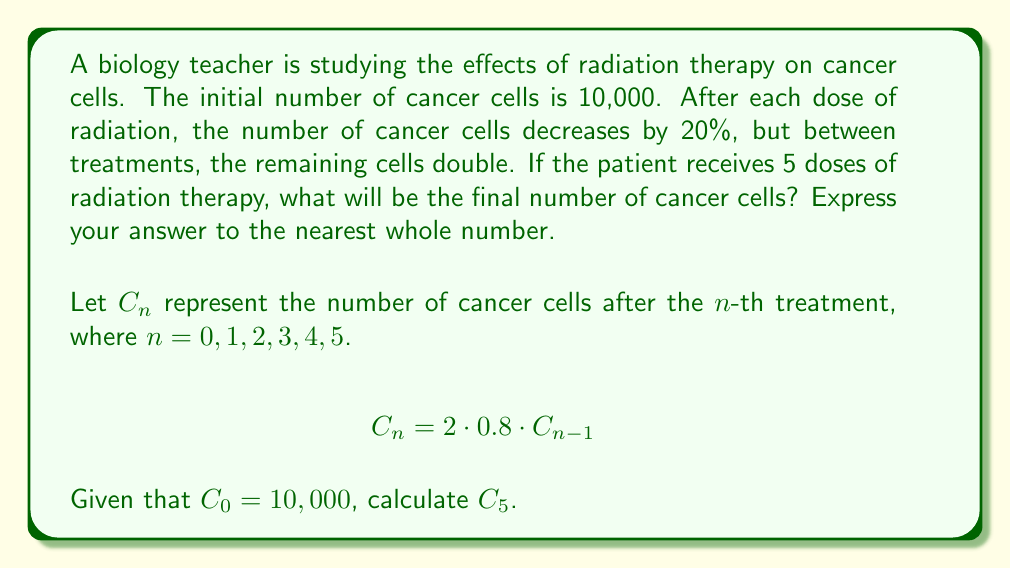Provide a solution to this math problem. Let's approach this step-by-step:

1) We start with $C_0 = 10,000$ cancer cells.

2) After each treatment, the number of cells is reduced by 20%, meaning 80% remain. Then, the remaining cells double before the next treatment. We can represent this with the equation:

   $$C_n = 2 \cdot 0.8 \cdot C_{n-1} = 1.6 \cdot C_{n-1}$$

3) Let's calculate the number of cells after each treatment:

   $C_1 = 1.6 \cdot C_0 = 1.6 \cdot 10,000 = 16,000$
   
   $C_2 = 1.6 \cdot C_1 = 1.6 \cdot 16,000 = 25,600$
   
   $C_3 = 1.6 \cdot C_2 = 1.6 \cdot 25,600 = 40,960$
   
   $C_4 = 1.6 \cdot C_3 = 1.6 \cdot 40,960 = 65,536$
   
   $C_5 = 1.6 \cdot C_4 = 1.6 \cdot 65,536 = 104,857.6$

4) Rounding to the nearest whole number, we get 104,858 cancer cells.

Alternatively, we could have used the formula:

$$C_5 = C_0 \cdot (1.6)^5 = 10,000 \cdot (1.6)^5 = 104,857.6$$

This yields the same result when rounded to the nearest whole number.
Answer: 104,858 cancer cells 